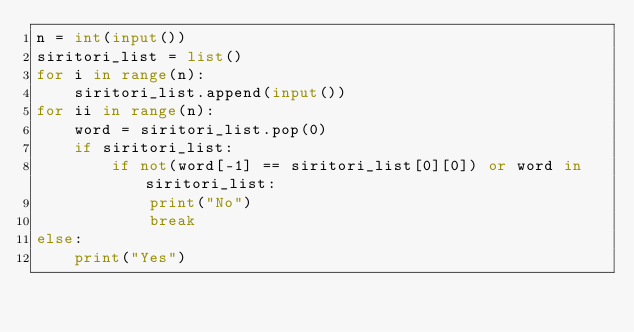<code> <loc_0><loc_0><loc_500><loc_500><_Python_>n = int(input())
siritori_list = list()
for i in range(n):
    siritori_list.append(input())
for ii in range(n):
    word = siritori_list.pop(0)
    if siritori_list:
        if not(word[-1] == siritori_list[0][0]) or word in siritori_list:
            print("No")
            break
else:
    print("Yes")</code> 